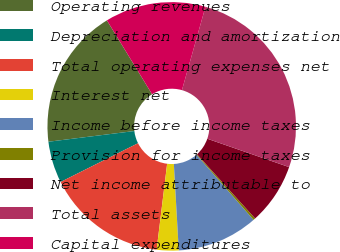<chart> <loc_0><loc_0><loc_500><loc_500><pie_chart><fcel>Operating revenues<fcel>Depreciation and amortization<fcel>Total operating expenses net<fcel>Interest net<fcel>Income before income taxes<fcel>Provision for income taxes<fcel>Net income attributable to<fcel>Total assets<fcel>Capital expenditures<nl><fcel>18.24%<fcel>5.41%<fcel>15.68%<fcel>2.84%<fcel>10.54%<fcel>0.27%<fcel>7.97%<fcel>25.94%<fcel>13.11%<nl></chart> 